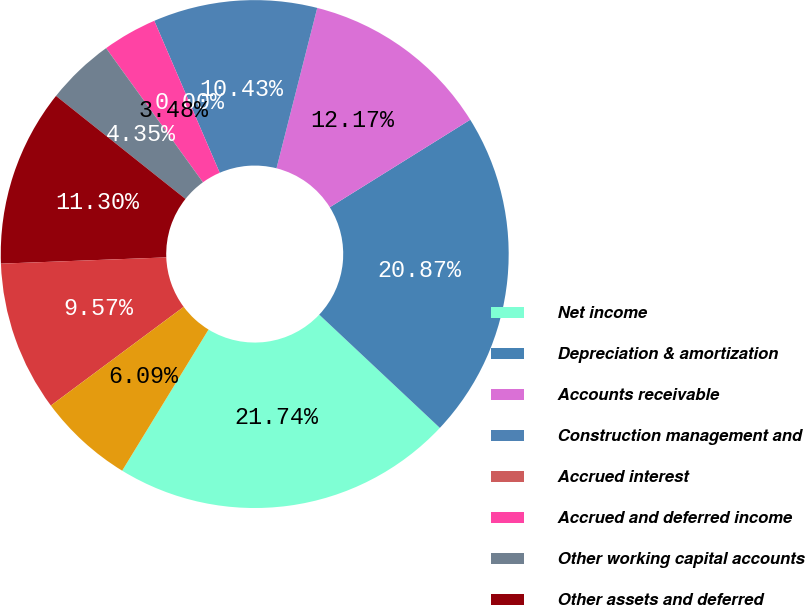<chart> <loc_0><loc_0><loc_500><loc_500><pie_chart><fcel>Net income<fcel>Depreciation & amortization<fcel>Accounts receivable<fcel>Construction management and<fcel>Accrued interest<fcel>Accrued and deferred income<fcel>Other working capital accounts<fcel>Other assets and deferred<fcel>Payment of hurricane related<fcel>Other Minority interest in<nl><fcel>21.74%<fcel>20.87%<fcel>12.17%<fcel>10.43%<fcel>0.0%<fcel>3.48%<fcel>4.35%<fcel>11.3%<fcel>9.57%<fcel>6.09%<nl></chart> 